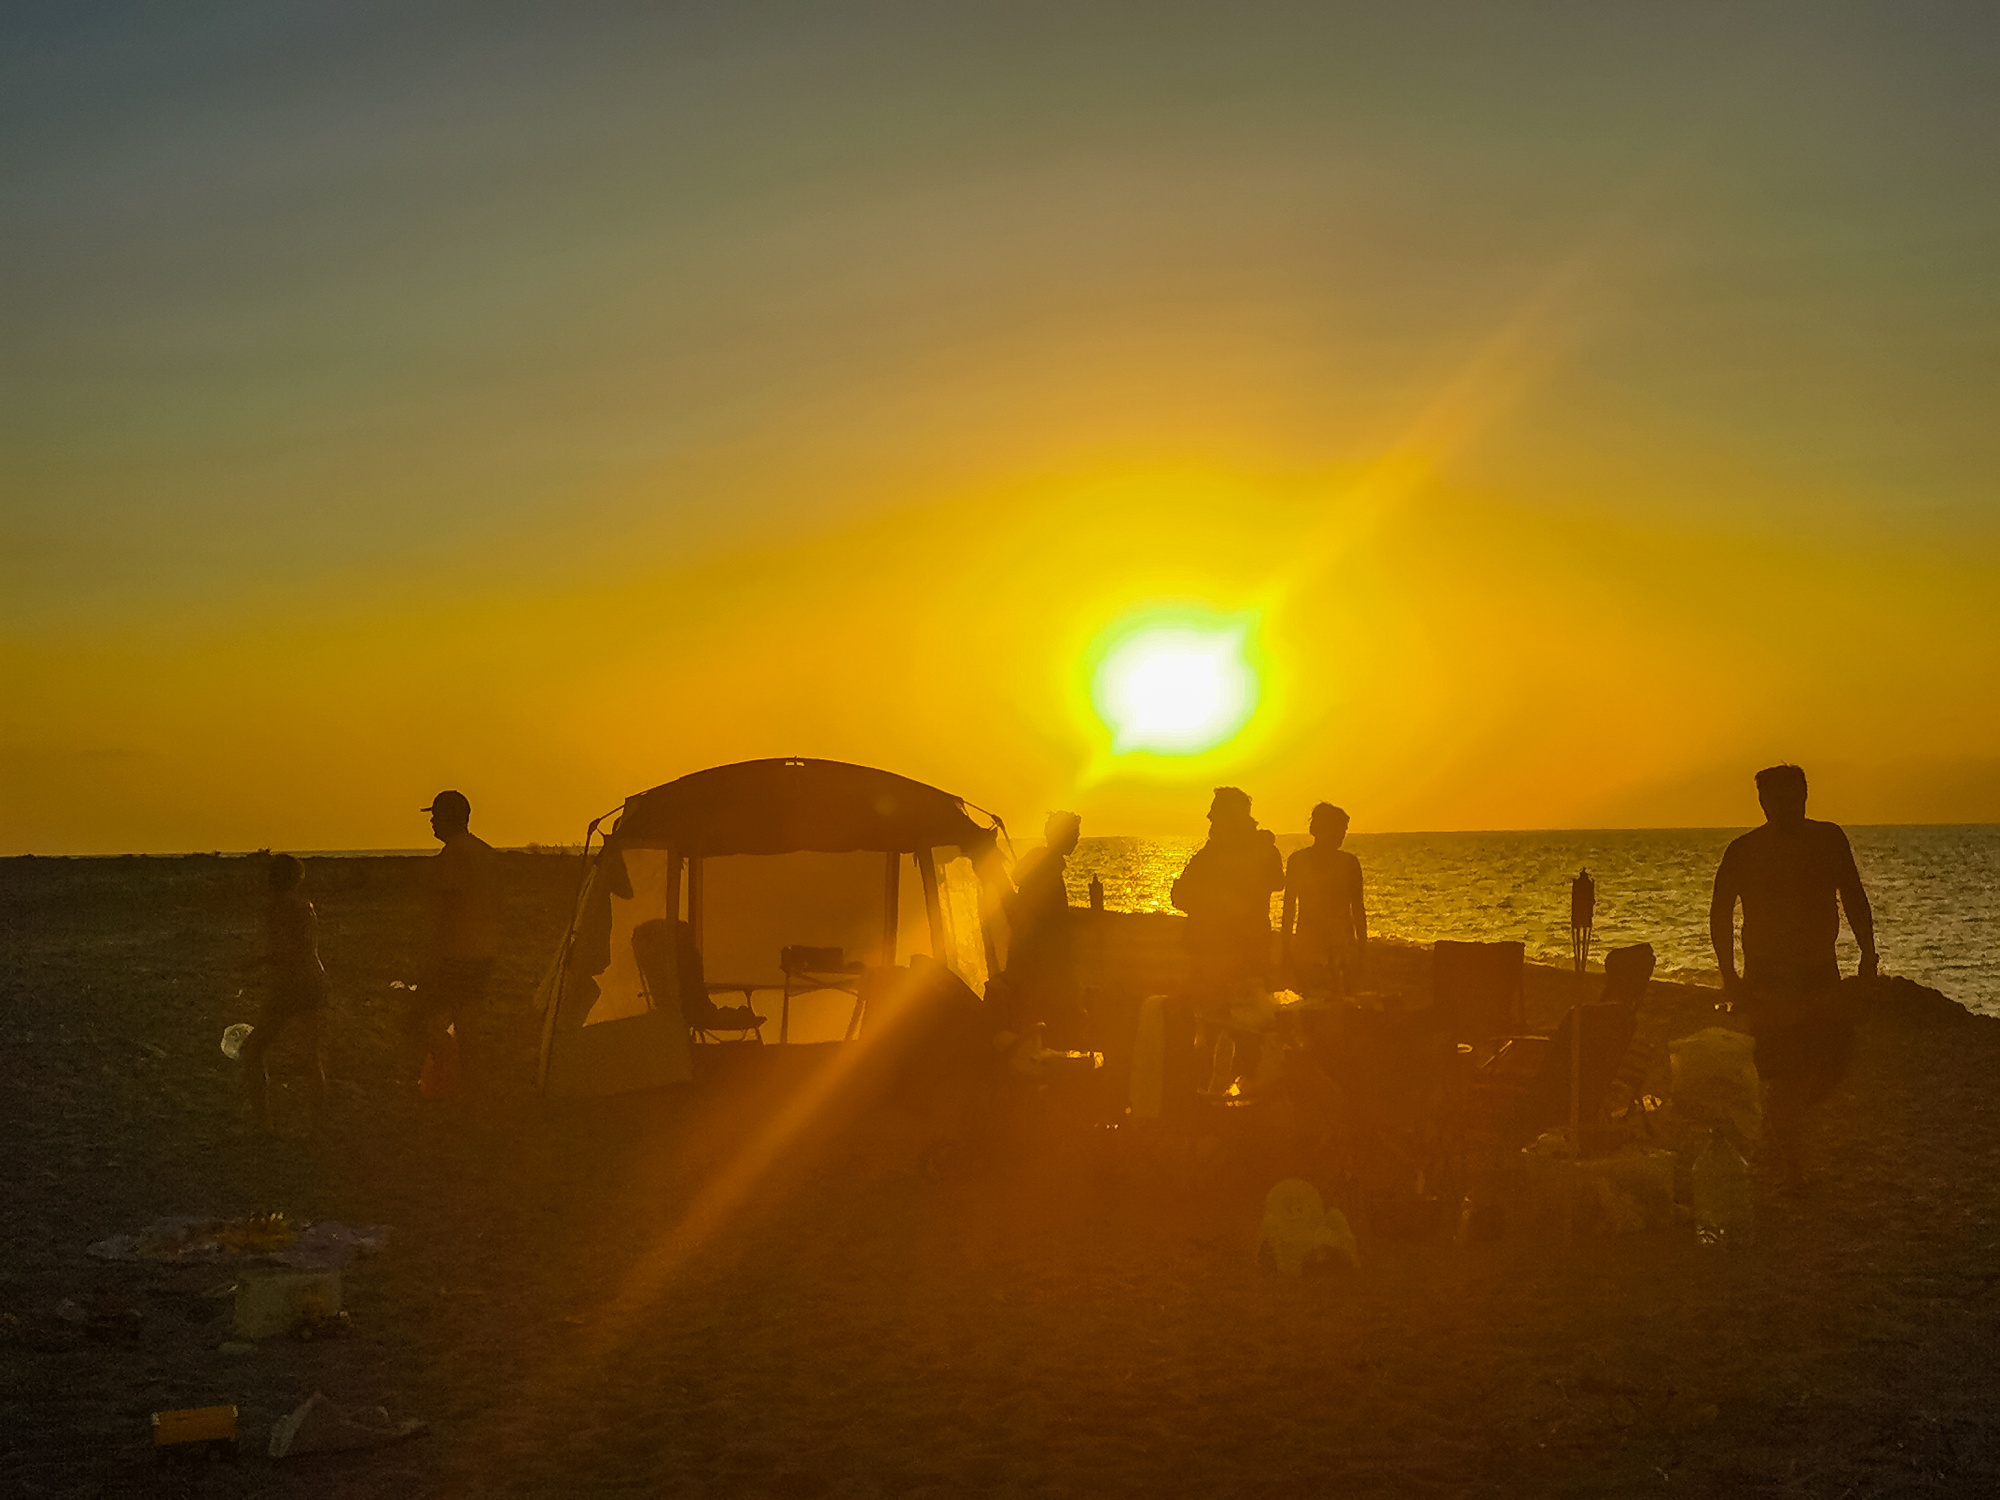What are the sensory experiences one might have in this setting? In this setting, the senses are awash with the textures and sounds of the seaside. Eyes are treated to a symphony of sunset hues, while noses might catch the dance of a gentle sea breeze with the faint hint of a beachside bonfire. The ears would pick up the medley of waves, playful yells, and the rustling of footsteps on sand, as the touch lingers on the grainy warmth still held by the ground, and the cool evening air that tickles the skin. 